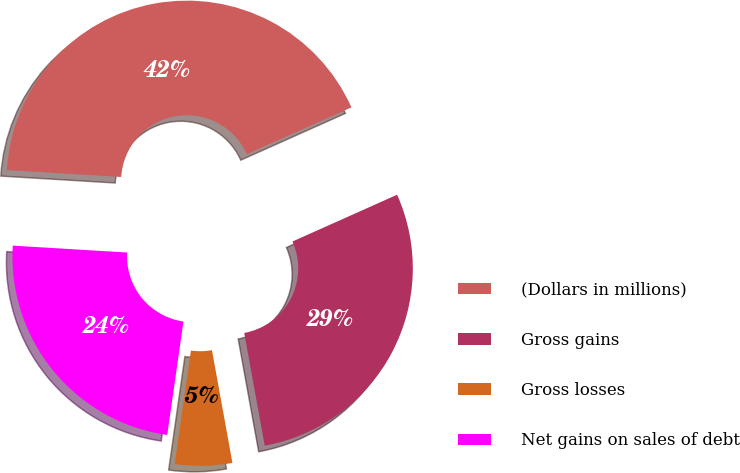<chart> <loc_0><loc_0><loc_500><loc_500><pie_chart><fcel>(Dollars in millions)<fcel>Gross gains<fcel>Gross losses<fcel>Net gains on sales of debt<nl><fcel>42.35%<fcel>28.83%<fcel>5.12%<fcel>23.7%<nl></chart> 